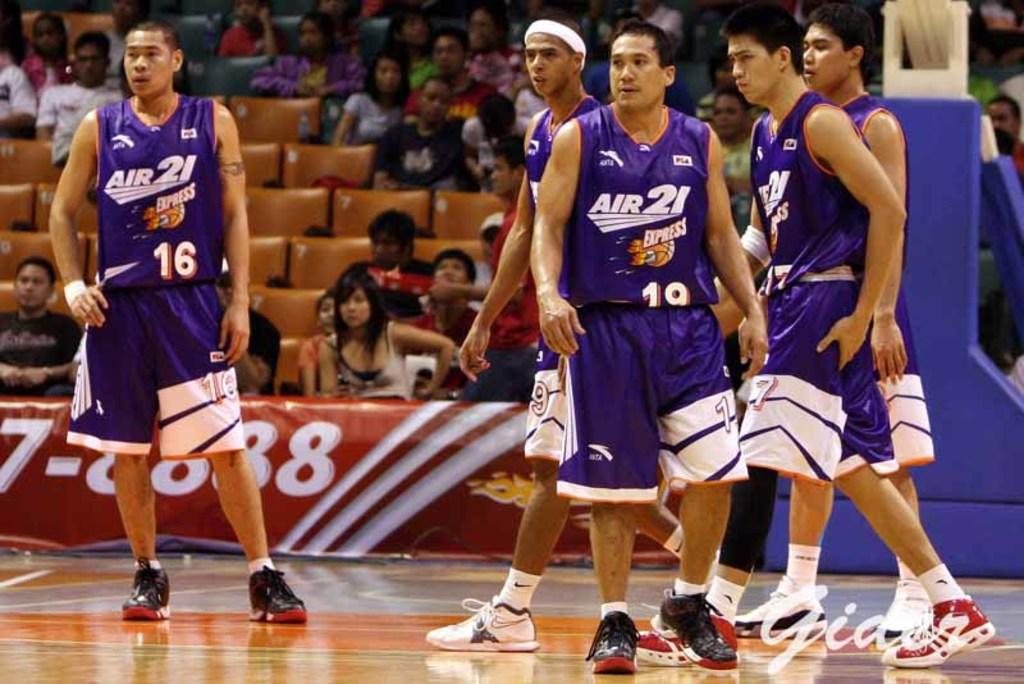What number is the person on the left?
Your response must be concise. 16. 